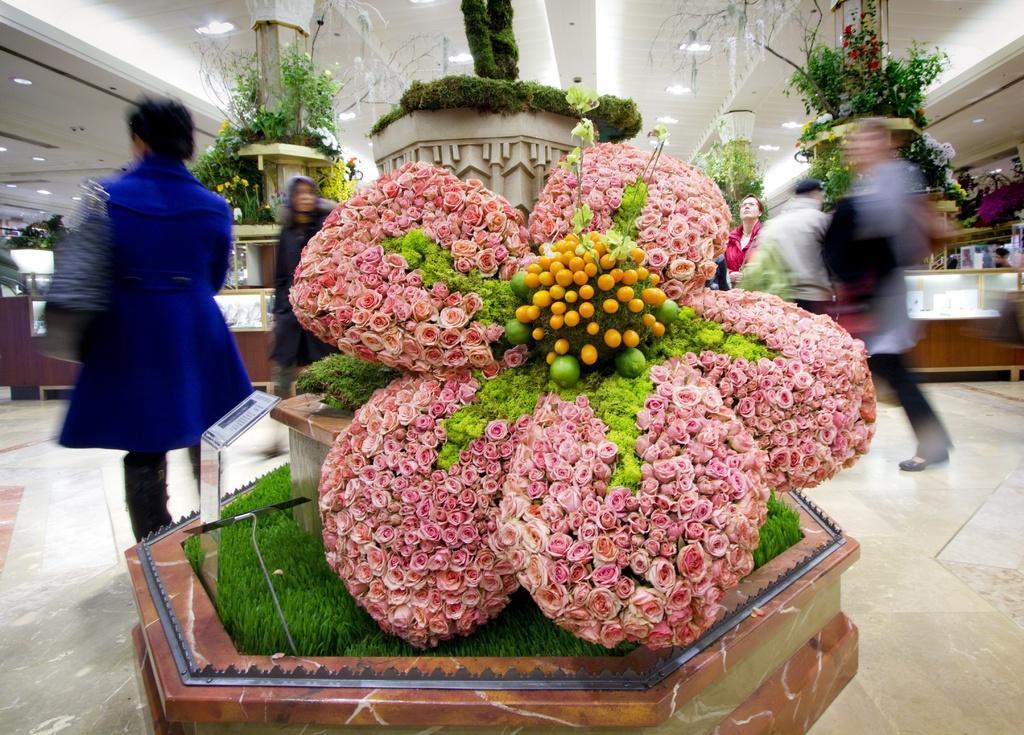Please provide a concise description of this image. In this image, we can see flowers, plants, few decorative objects. On the right side and left side, we can see few people, some objects, floor and few things. Top of the image, we can see the ceiling and lights. 